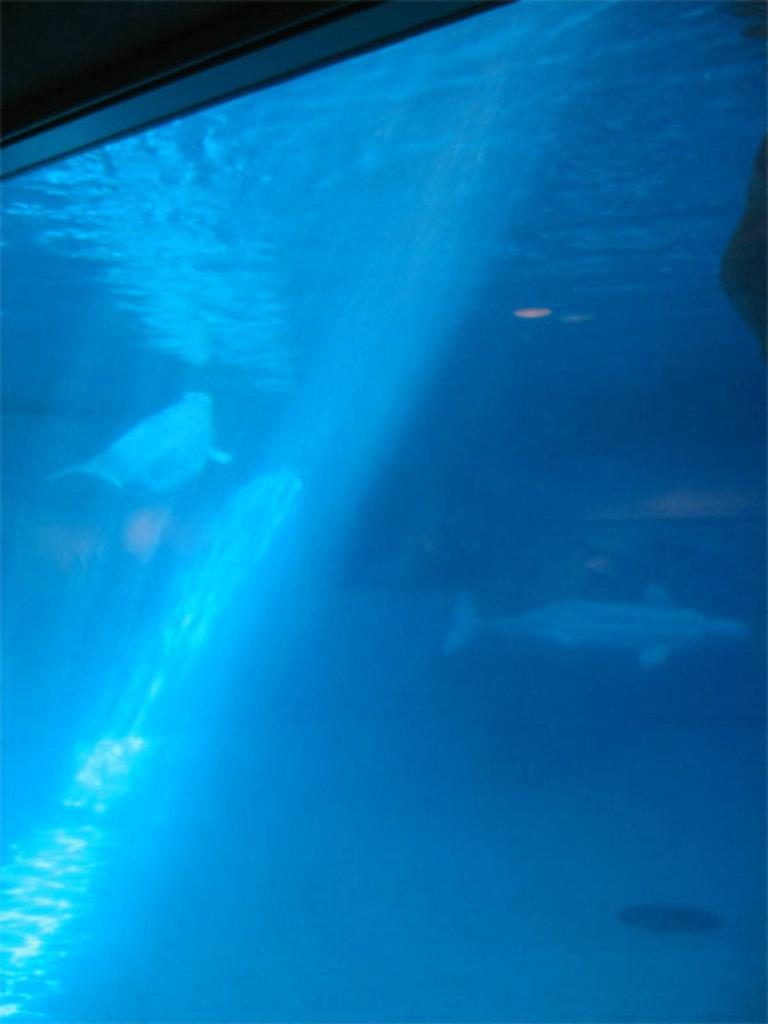What animals are present in the image? There are two fish in the image. Where are the fish located? The fish are in an aquarium. What type of guitar can be seen in the image? There is no guitar present in the image; it features two fish in an aquarium. Is there a tent visible in the image? No, there is no tent present in the image. 